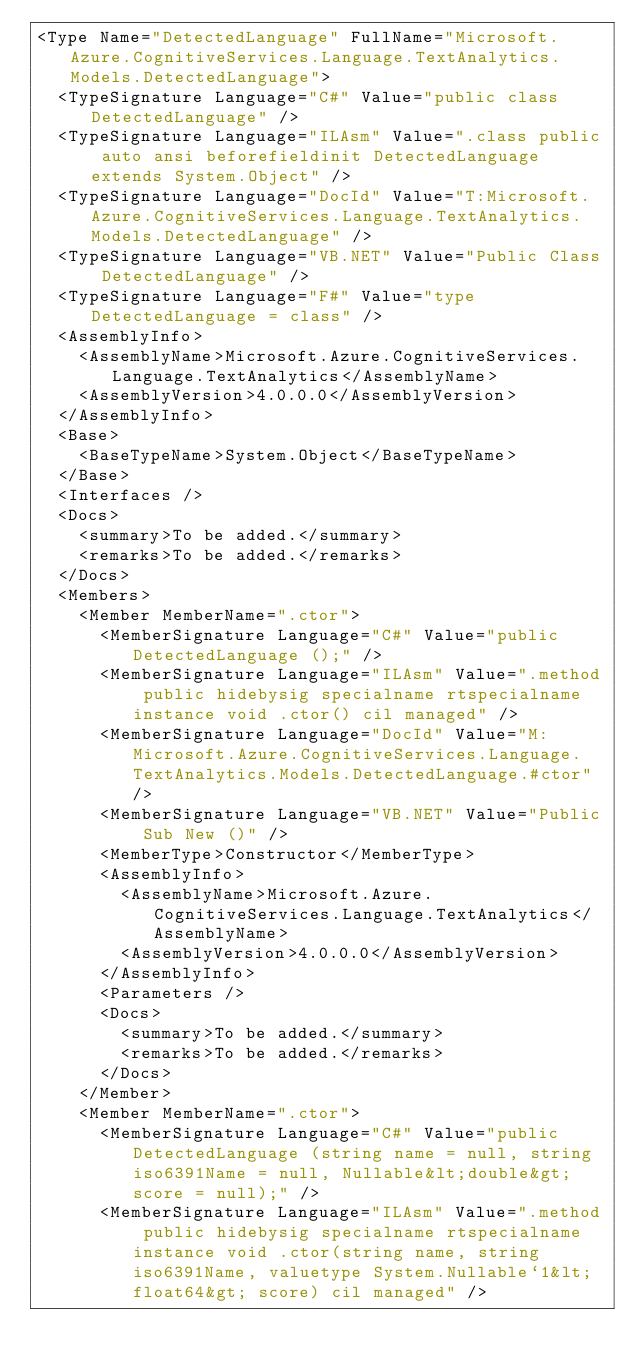Convert code to text. <code><loc_0><loc_0><loc_500><loc_500><_XML_><Type Name="DetectedLanguage" FullName="Microsoft.Azure.CognitiveServices.Language.TextAnalytics.Models.DetectedLanguage">
  <TypeSignature Language="C#" Value="public class DetectedLanguage" />
  <TypeSignature Language="ILAsm" Value=".class public auto ansi beforefieldinit DetectedLanguage extends System.Object" />
  <TypeSignature Language="DocId" Value="T:Microsoft.Azure.CognitiveServices.Language.TextAnalytics.Models.DetectedLanguage" />
  <TypeSignature Language="VB.NET" Value="Public Class DetectedLanguage" />
  <TypeSignature Language="F#" Value="type DetectedLanguage = class" />
  <AssemblyInfo>
    <AssemblyName>Microsoft.Azure.CognitiveServices.Language.TextAnalytics</AssemblyName>
    <AssemblyVersion>4.0.0.0</AssemblyVersion>
  </AssemblyInfo>
  <Base>
    <BaseTypeName>System.Object</BaseTypeName>
  </Base>
  <Interfaces />
  <Docs>
    <summary>To be added.</summary>
    <remarks>To be added.</remarks>
  </Docs>
  <Members>
    <Member MemberName=".ctor">
      <MemberSignature Language="C#" Value="public DetectedLanguage ();" />
      <MemberSignature Language="ILAsm" Value=".method public hidebysig specialname rtspecialname instance void .ctor() cil managed" />
      <MemberSignature Language="DocId" Value="M:Microsoft.Azure.CognitiveServices.Language.TextAnalytics.Models.DetectedLanguage.#ctor" />
      <MemberSignature Language="VB.NET" Value="Public Sub New ()" />
      <MemberType>Constructor</MemberType>
      <AssemblyInfo>
        <AssemblyName>Microsoft.Azure.CognitiveServices.Language.TextAnalytics</AssemblyName>
        <AssemblyVersion>4.0.0.0</AssemblyVersion>
      </AssemblyInfo>
      <Parameters />
      <Docs>
        <summary>To be added.</summary>
        <remarks>To be added.</remarks>
      </Docs>
    </Member>
    <Member MemberName=".ctor">
      <MemberSignature Language="C#" Value="public DetectedLanguage (string name = null, string iso6391Name = null, Nullable&lt;double&gt; score = null);" />
      <MemberSignature Language="ILAsm" Value=".method public hidebysig specialname rtspecialname instance void .ctor(string name, string iso6391Name, valuetype System.Nullable`1&lt;float64&gt; score) cil managed" /></code> 